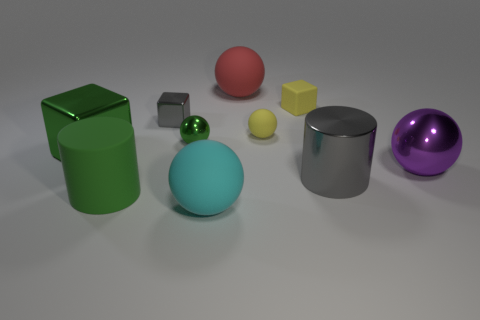Subtract 2 spheres. How many spheres are left? 3 Subtract all green balls. How many balls are left? 4 Subtract all brown spheres. Subtract all purple cubes. How many spheres are left? 5 Subtract all cylinders. How many objects are left? 8 Subtract all shiny spheres. Subtract all gray cylinders. How many objects are left? 7 Add 8 large cubes. How many large cubes are left? 9 Add 5 yellow balls. How many yellow balls exist? 6 Subtract 0 red cubes. How many objects are left? 10 